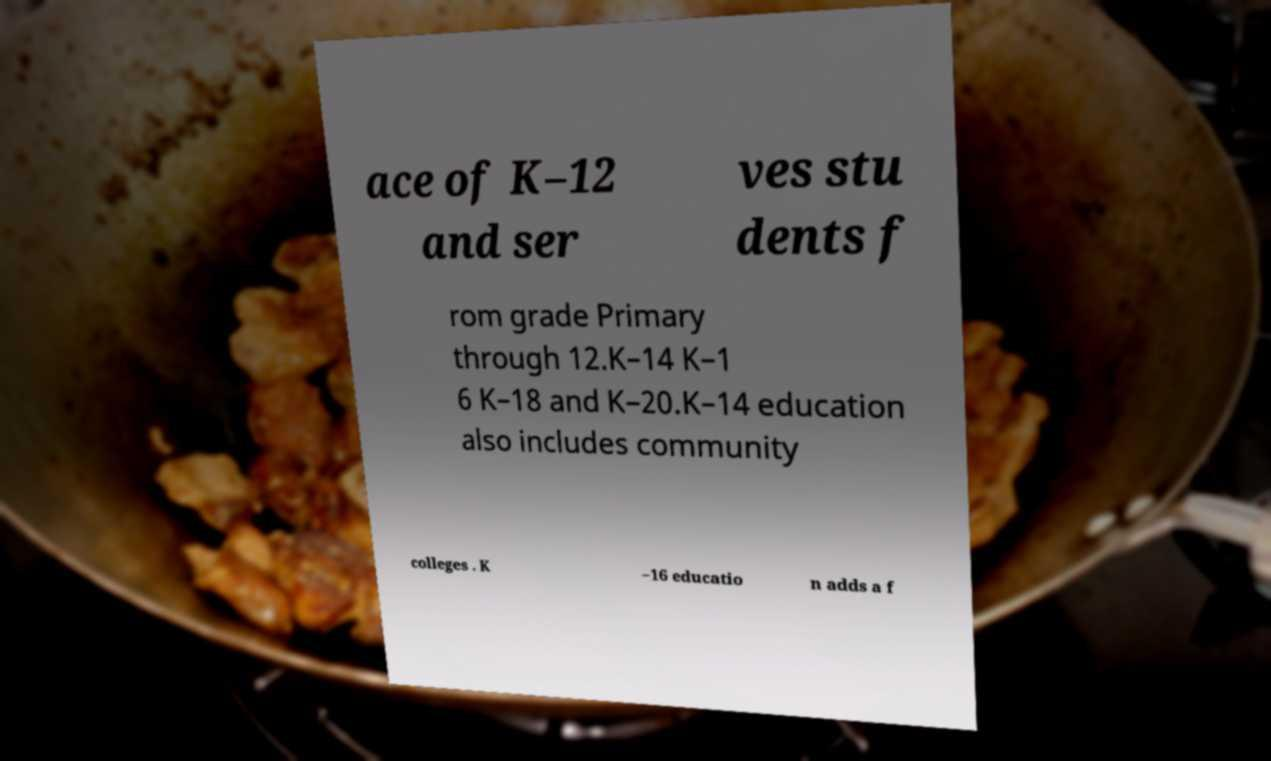Could you assist in decoding the text presented in this image and type it out clearly? ace of K–12 and ser ves stu dents f rom grade Primary through 12.K–14 K–1 6 K–18 and K–20.K–14 education also includes community colleges . K –16 educatio n adds a f 